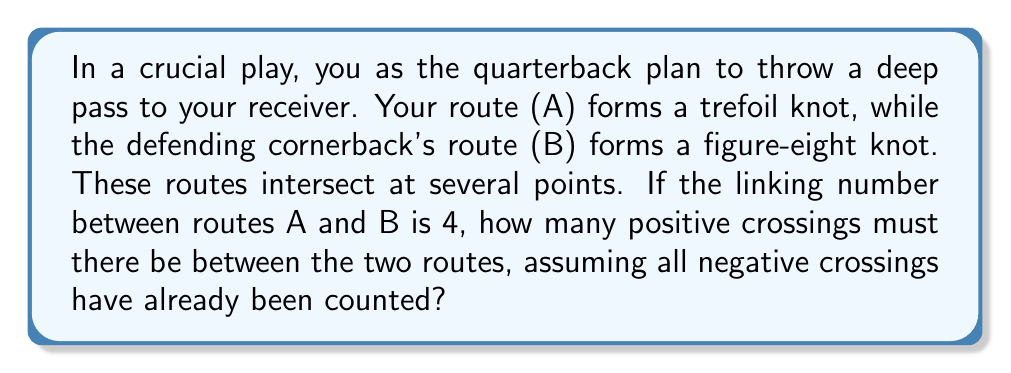Teach me how to tackle this problem. Let's approach this step-by-step:

1) The linking number is defined as:

   $$ \text{Lk}(A,B) = \frac{1}{2}(\text{number of positive crossings} - \text{number of negative crossings}) $$

2) We're given that the linking number is 4:

   $$ \text{Lk}(A,B) = 4 $$

3) Let's denote the number of positive crossings as $p$ and the number of negative crossings as $n$. We can write:

   $$ 4 = \frac{1}{2}(p - n) $$

4) Multiply both sides by 2:

   $$ 8 = p - n $$

5) We're told that all negative crossings have already been counted. This means we know $n$, but we need to find $p$.

6) Rearrange the equation:

   $$ p = 8 + n $$

7) This tells us that the number of positive crossings must be 8 more than the number of negative crossings, regardless of what $n$ is.

Therefore, there must be 8 more positive crossings than negative crossings to achieve a linking number of 4.
Answer: 8 